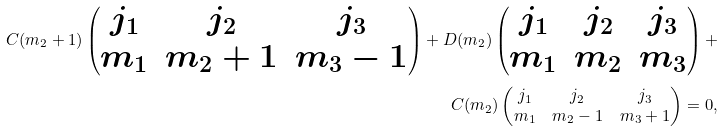<formula> <loc_0><loc_0><loc_500><loc_500>C ( m _ { 2 } + 1 ) \begin{pmatrix} j _ { 1 } & j _ { 2 } & j _ { 3 } \\ m _ { 1 } & m _ { 2 } + 1 & m _ { 3 } - 1 \end{pmatrix} + D ( m _ { 2 } ) \begin{pmatrix} j _ { 1 } & j _ { 2 } & j _ { 3 } \\ m _ { 1 } & m _ { 2 } & m _ { 3 } \end{pmatrix} + \\ C ( m _ { 2 } ) \begin{pmatrix} j _ { 1 } & j _ { 2 } & j _ { 3 } \\ m _ { 1 } & m _ { 2 } - 1 & m _ { 3 } + 1 \end{pmatrix} = 0 ,</formula> 